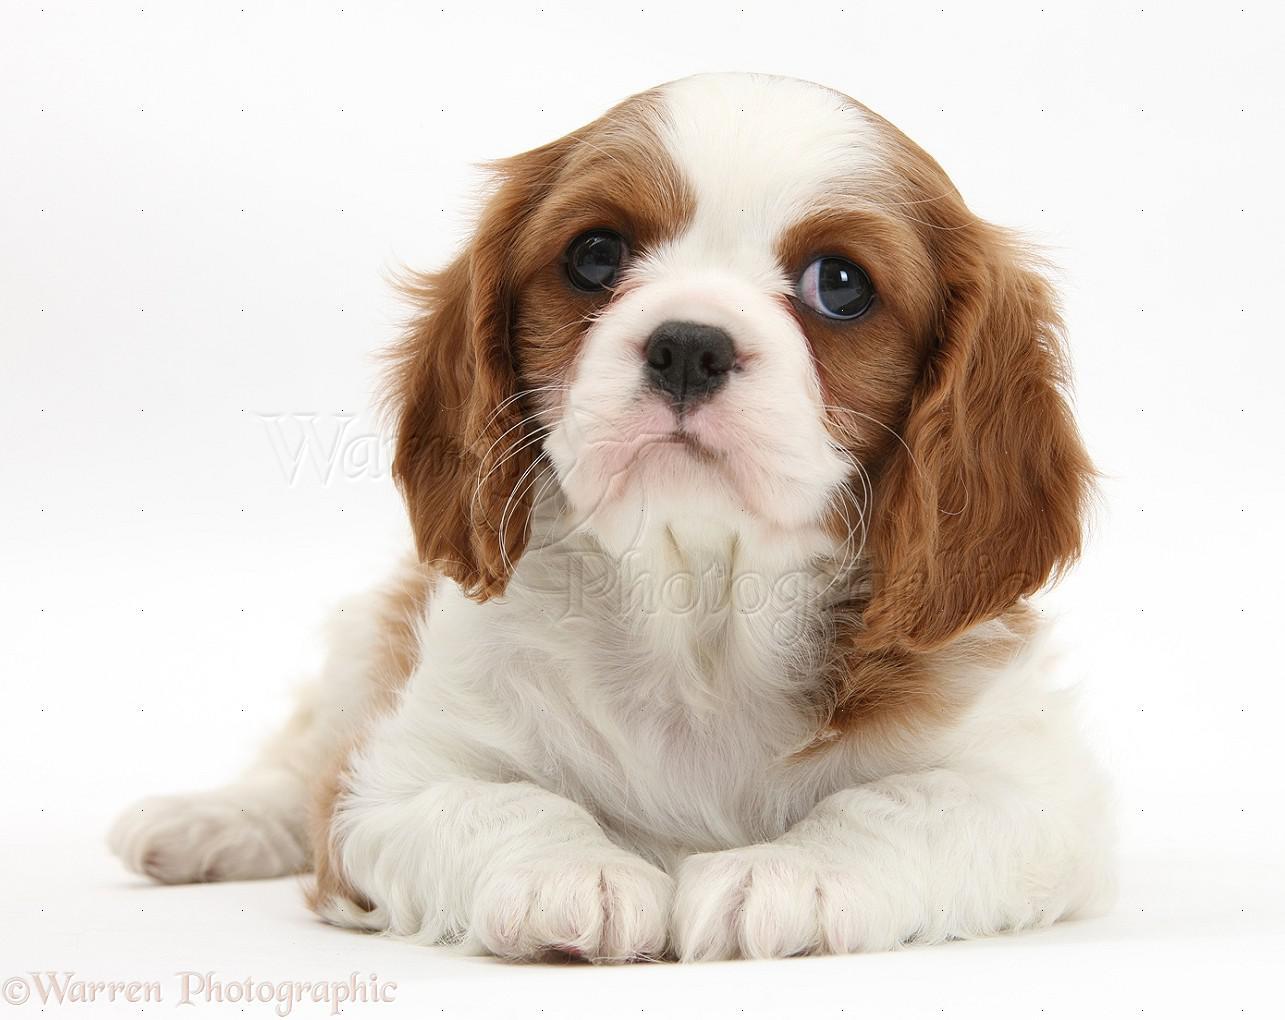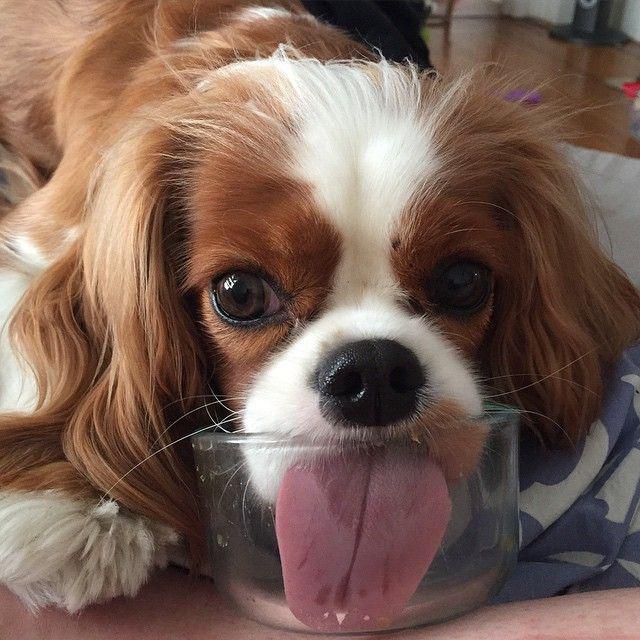The first image is the image on the left, the second image is the image on the right. Considering the images on both sides, is "The dog in the image on the left is outside." valid? Answer yes or no. No. 